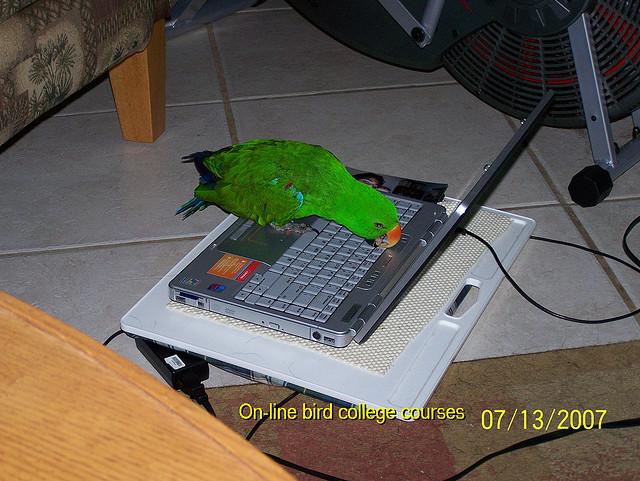What is the bird sitting on?
Give a very brief answer. Laptop. Does the bird feel the heat?
Write a very short answer. Yes. What website is the bird looking at?
Write a very short answer. Don't know. 